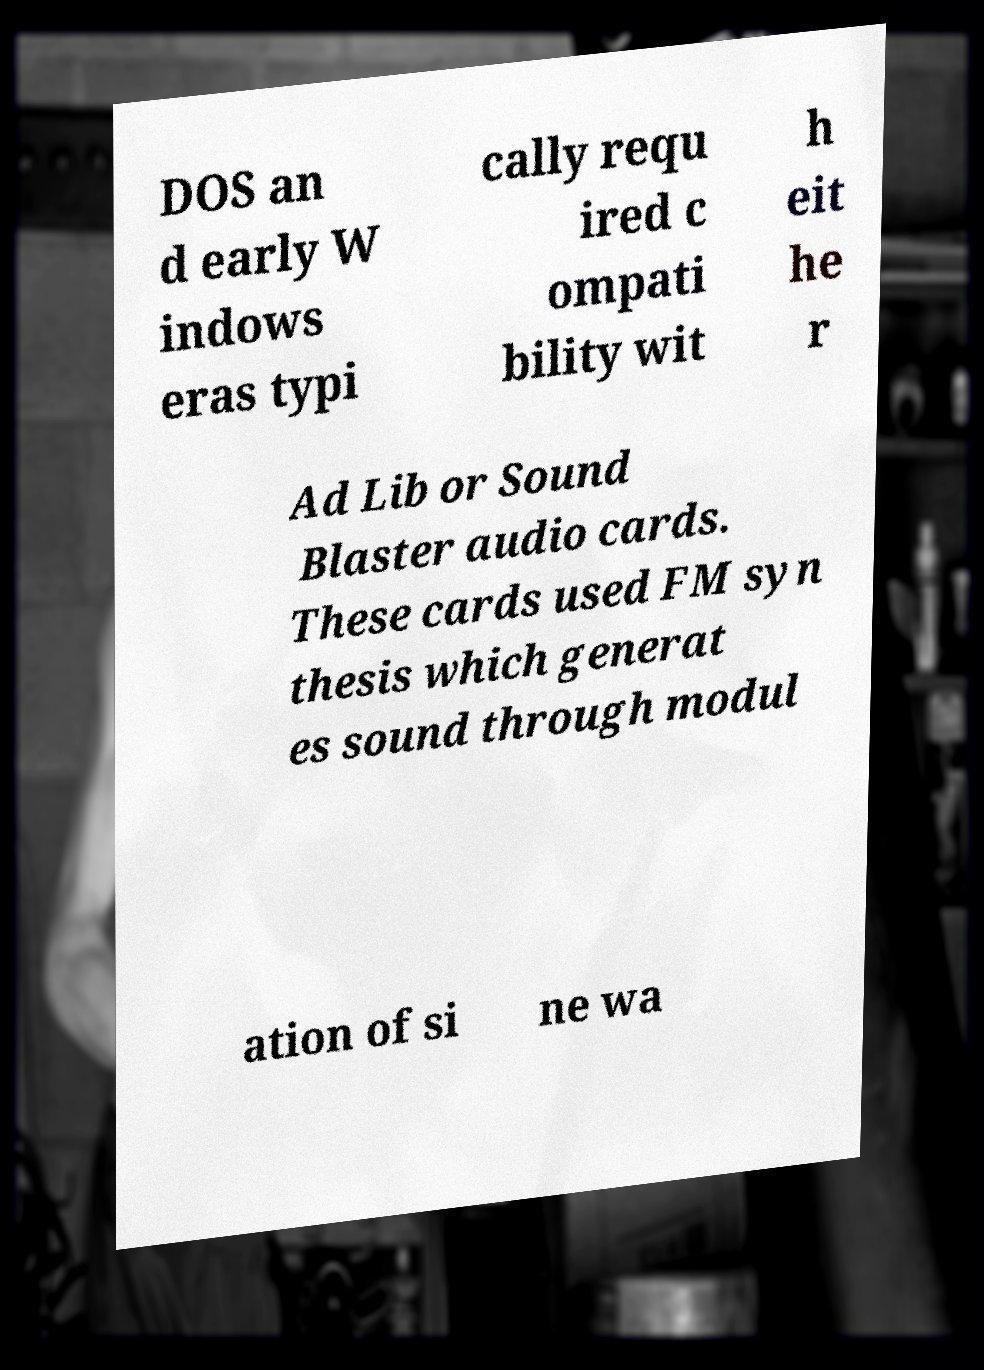Can you read and provide the text displayed in the image?This photo seems to have some interesting text. Can you extract and type it out for me? DOS an d early W indows eras typi cally requ ired c ompati bility wit h eit he r Ad Lib or Sound Blaster audio cards. These cards used FM syn thesis which generat es sound through modul ation of si ne wa 